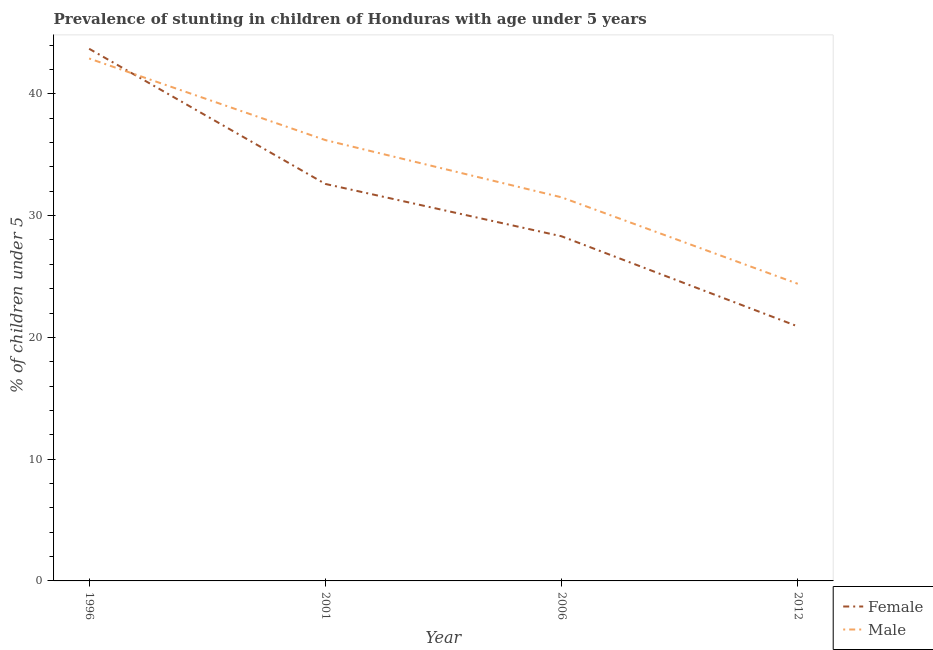How many different coloured lines are there?
Give a very brief answer. 2. Does the line corresponding to percentage of stunted male children intersect with the line corresponding to percentage of stunted female children?
Provide a succinct answer. Yes. What is the percentage of stunted female children in 2001?
Provide a short and direct response. 32.6. Across all years, what is the maximum percentage of stunted male children?
Offer a very short reply. 42.9. Across all years, what is the minimum percentage of stunted male children?
Offer a very short reply. 24.4. In which year was the percentage of stunted female children maximum?
Provide a succinct answer. 1996. What is the total percentage of stunted male children in the graph?
Your answer should be very brief. 135. What is the difference between the percentage of stunted male children in 1996 and that in 2006?
Your answer should be compact. 11.4. What is the difference between the percentage of stunted male children in 2006 and the percentage of stunted female children in 2001?
Provide a succinct answer. -1.1. What is the average percentage of stunted female children per year?
Make the answer very short. 31.37. In the year 2006, what is the difference between the percentage of stunted male children and percentage of stunted female children?
Your response must be concise. 3.2. In how many years, is the percentage of stunted female children greater than 14 %?
Keep it short and to the point. 4. What is the ratio of the percentage of stunted female children in 1996 to that in 2006?
Keep it short and to the point. 1.54. Is the difference between the percentage of stunted female children in 1996 and 2006 greater than the difference between the percentage of stunted male children in 1996 and 2006?
Provide a short and direct response. Yes. What is the difference between the highest and the second highest percentage of stunted female children?
Provide a succinct answer. 11.1. What is the difference between the highest and the lowest percentage of stunted female children?
Your answer should be compact. 22.8. In how many years, is the percentage of stunted female children greater than the average percentage of stunted female children taken over all years?
Give a very brief answer. 2. Is the sum of the percentage of stunted male children in 1996 and 2001 greater than the maximum percentage of stunted female children across all years?
Keep it short and to the point. Yes. Does the percentage of stunted female children monotonically increase over the years?
Your response must be concise. No. What is the difference between two consecutive major ticks on the Y-axis?
Make the answer very short. 10. Are the values on the major ticks of Y-axis written in scientific E-notation?
Offer a very short reply. No. Does the graph contain any zero values?
Your answer should be compact. No. How many legend labels are there?
Make the answer very short. 2. How are the legend labels stacked?
Ensure brevity in your answer.  Vertical. What is the title of the graph?
Your response must be concise. Prevalence of stunting in children of Honduras with age under 5 years. Does "Agricultural land" appear as one of the legend labels in the graph?
Your answer should be very brief. No. What is the label or title of the X-axis?
Offer a very short reply. Year. What is the label or title of the Y-axis?
Your answer should be very brief.  % of children under 5. What is the  % of children under 5 of Female in 1996?
Ensure brevity in your answer.  43.7. What is the  % of children under 5 of Male in 1996?
Provide a short and direct response. 42.9. What is the  % of children under 5 in Female in 2001?
Your response must be concise. 32.6. What is the  % of children under 5 in Male in 2001?
Offer a very short reply. 36.2. What is the  % of children under 5 of Female in 2006?
Provide a succinct answer. 28.3. What is the  % of children under 5 of Male in 2006?
Your answer should be compact. 31.5. What is the  % of children under 5 of Female in 2012?
Your response must be concise. 20.9. What is the  % of children under 5 in Male in 2012?
Offer a very short reply. 24.4. Across all years, what is the maximum  % of children under 5 of Female?
Provide a short and direct response. 43.7. Across all years, what is the maximum  % of children under 5 in Male?
Your answer should be compact. 42.9. Across all years, what is the minimum  % of children under 5 of Female?
Offer a terse response. 20.9. Across all years, what is the minimum  % of children under 5 of Male?
Offer a very short reply. 24.4. What is the total  % of children under 5 of Female in the graph?
Your response must be concise. 125.5. What is the total  % of children under 5 of Male in the graph?
Your answer should be compact. 135. What is the difference between the  % of children under 5 in Female in 1996 and that in 2001?
Your answer should be very brief. 11.1. What is the difference between the  % of children under 5 of Male in 1996 and that in 2001?
Provide a short and direct response. 6.7. What is the difference between the  % of children under 5 in Male in 1996 and that in 2006?
Provide a short and direct response. 11.4. What is the difference between the  % of children under 5 of Female in 1996 and that in 2012?
Your answer should be very brief. 22.8. What is the difference between the  % of children under 5 of Male in 1996 and that in 2012?
Ensure brevity in your answer.  18.5. What is the difference between the  % of children under 5 in Female in 2001 and that in 2012?
Make the answer very short. 11.7. What is the difference between the  % of children under 5 of Male in 2001 and that in 2012?
Offer a terse response. 11.8. What is the difference between the  % of children under 5 in Male in 2006 and that in 2012?
Your response must be concise. 7.1. What is the difference between the  % of children under 5 of Female in 1996 and the  % of children under 5 of Male in 2001?
Ensure brevity in your answer.  7.5. What is the difference between the  % of children under 5 of Female in 1996 and the  % of children under 5 of Male in 2012?
Offer a very short reply. 19.3. What is the difference between the  % of children under 5 in Female in 2006 and the  % of children under 5 in Male in 2012?
Ensure brevity in your answer.  3.9. What is the average  % of children under 5 of Female per year?
Keep it short and to the point. 31.38. What is the average  % of children under 5 of Male per year?
Offer a very short reply. 33.75. In the year 1996, what is the difference between the  % of children under 5 of Female and  % of children under 5 of Male?
Your answer should be compact. 0.8. In the year 2012, what is the difference between the  % of children under 5 of Female and  % of children under 5 of Male?
Your answer should be very brief. -3.5. What is the ratio of the  % of children under 5 of Female in 1996 to that in 2001?
Offer a terse response. 1.34. What is the ratio of the  % of children under 5 of Male in 1996 to that in 2001?
Offer a terse response. 1.19. What is the ratio of the  % of children under 5 of Female in 1996 to that in 2006?
Offer a terse response. 1.54. What is the ratio of the  % of children under 5 of Male in 1996 to that in 2006?
Make the answer very short. 1.36. What is the ratio of the  % of children under 5 of Female in 1996 to that in 2012?
Offer a terse response. 2.09. What is the ratio of the  % of children under 5 of Male in 1996 to that in 2012?
Your response must be concise. 1.76. What is the ratio of the  % of children under 5 of Female in 2001 to that in 2006?
Your answer should be compact. 1.15. What is the ratio of the  % of children under 5 in Male in 2001 to that in 2006?
Offer a very short reply. 1.15. What is the ratio of the  % of children under 5 of Female in 2001 to that in 2012?
Ensure brevity in your answer.  1.56. What is the ratio of the  % of children under 5 of Male in 2001 to that in 2012?
Your answer should be very brief. 1.48. What is the ratio of the  % of children under 5 in Female in 2006 to that in 2012?
Keep it short and to the point. 1.35. What is the ratio of the  % of children under 5 of Male in 2006 to that in 2012?
Offer a very short reply. 1.29. What is the difference between the highest and the second highest  % of children under 5 of Female?
Your answer should be very brief. 11.1. What is the difference between the highest and the lowest  % of children under 5 in Female?
Give a very brief answer. 22.8. What is the difference between the highest and the lowest  % of children under 5 of Male?
Your answer should be very brief. 18.5. 